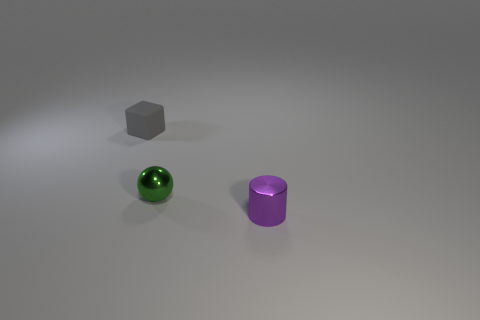Is there anything else that has the same material as the block?
Your answer should be very brief. No. What number of objects are either purple rubber things or objects that are in front of the gray object?
Provide a short and direct response. 2. What is the shape of the gray thing?
Provide a succinct answer. Cube. What is the shape of the thing that is in front of the tiny metal object that is behind the purple metal cylinder?
Your response must be concise. Cylinder. There is a small cylinder that is the same material as the sphere; what color is it?
Keep it short and to the point. Purple. Is the number of small purple cylinders that are in front of the small rubber cube greater than the number of small cubes in front of the small green thing?
Ensure brevity in your answer.  Yes. Is there any other thing that has the same shape as the small green metal thing?
Provide a short and direct response. No. Is the shape of the gray matte object the same as the tiny thing on the right side of the green thing?
Provide a short and direct response. No. How many other things are there of the same material as the tiny purple thing?
Your answer should be compact. 1. Is the color of the metal cylinder the same as the small metallic object behind the tiny cylinder?
Ensure brevity in your answer.  No. 